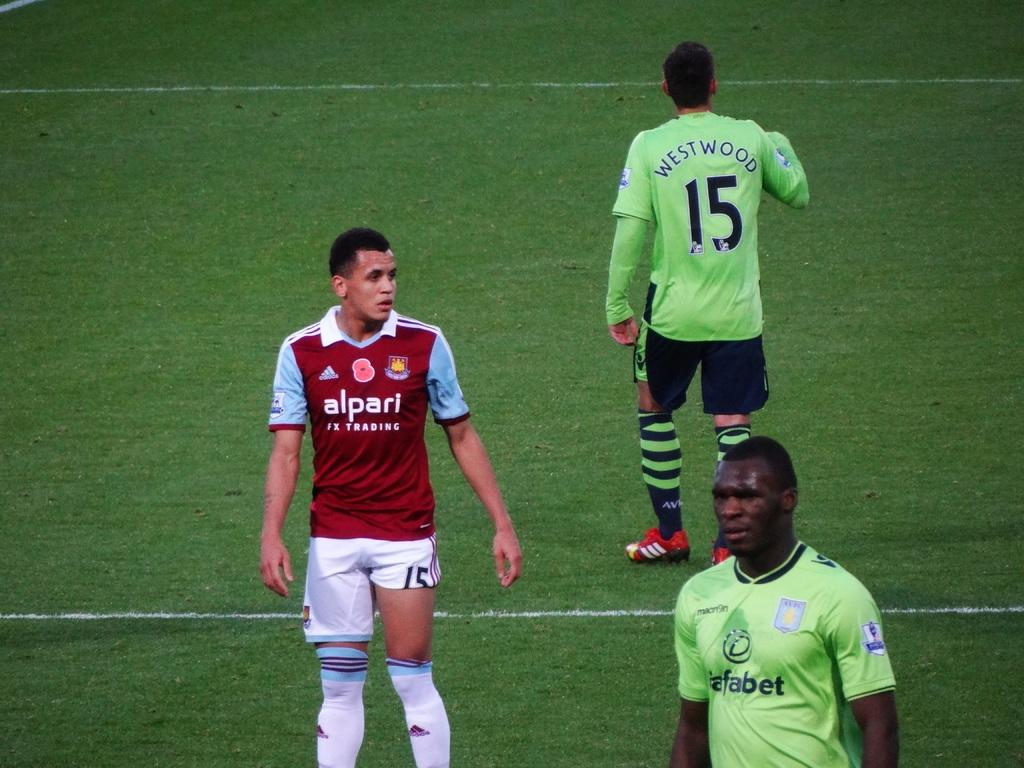<image>
Render a clear and concise summary of the photo. 3 soccer players can be seen, with 15 facing away from the camera 